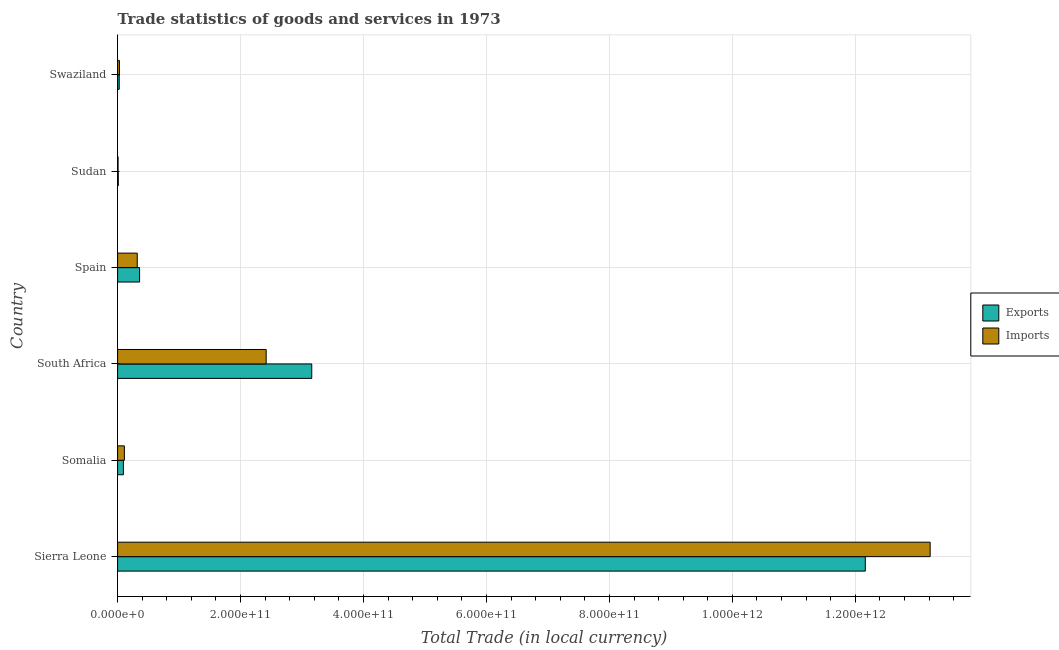How many different coloured bars are there?
Keep it short and to the point. 2. Are the number of bars per tick equal to the number of legend labels?
Offer a very short reply. Yes. How many bars are there on the 3rd tick from the bottom?
Make the answer very short. 2. What is the export of goods and services in Swaziland?
Your response must be concise. 2.62e+09. Across all countries, what is the maximum export of goods and services?
Provide a succinct answer. 1.22e+12. Across all countries, what is the minimum export of goods and services?
Give a very brief answer. 1.12e+09. In which country was the export of goods and services maximum?
Give a very brief answer. Sierra Leone. In which country was the export of goods and services minimum?
Your response must be concise. Sudan. What is the total export of goods and services in the graph?
Provide a succinct answer. 1.58e+12. What is the difference between the imports of goods and services in Somalia and that in Spain?
Provide a succinct answer. -2.10e+1. What is the difference between the imports of goods and services in Somalia and the export of goods and services in South Africa?
Provide a short and direct response. -3.05e+11. What is the average export of goods and services per country?
Provide a succinct answer. 2.63e+11. What is the difference between the imports of goods and services and export of goods and services in Sierra Leone?
Ensure brevity in your answer.  1.06e+11. In how many countries, is the imports of goods and services greater than 280000000000 LCU?
Provide a succinct answer. 1. What is the ratio of the export of goods and services in Somalia to that in Spain?
Ensure brevity in your answer.  0.26. Is the imports of goods and services in South Africa less than that in Swaziland?
Your answer should be very brief. No. Is the difference between the export of goods and services in Sierra Leone and Sudan greater than the difference between the imports of goods and services in Sierra Leone and Sudan?
Your response must be concise. No. What is the difference between the highest and the second highest imports of goods and services?
Keep it short and to the point. 1.08e+12. What is the difference between the highest and the lowest imports of goods and services?
Your answer should be very brief. 1.32e+12. In how many countries, is the export of goods and services greater than the average export of goods and services taken over all countries?
Your answer should be very brief. 2. Is the sum of the export of goods and services in Somalia and Sudan greater than the maximum imports of goods and services across all countries?
Your answer should be compact. No. What does the 2nd bar from the top in Spain represents?
Offer a very short reply. Exports. What does the 1st bar from the bottom in Spain represents?
Provide a short and direct response. Exports. How many bars are there?
Your response must be concise. 12. Are all the bars in the graph horizontal?
Offer a very short reply. Yes. How many countries are there in the graph?
Provide a succinct answer. 6. What is the difference between two consecutive major ticks on the X-axis?
Your answer should be compact. 2.00e+11. Does the graph contain grids?
Provide a short and direct response. Yes. Where does the legend appear in the graph?
Provide a short and direct response. Center right. How are the legend labels stacked?
Your answer should be compact. Vertical. What is the title of the graph?
Offer a very short reply. Trade statistics of goods and services in 1973. Does "Fraud firms" appear as one of the legend labels in the graph?
Your answer should be compact. No. What is the label or title of the X-axis?
Make the answer very short. Total Trade (in local currency). What is the label or title of the Y-axis?
Provide a short and direct response. Country. What is the Total Trade (in local currency) in Exports in Sierra Leone?
Provide a short and direct response. 1.22e+12. What is the Total Trade (in local currency) of Imports in Sierra Leone?
Provide a succinct answer. 1.32e+12. What is the Total Trade (in local currency) of Exports in Somalia?
Offer a very short reply. 9.41e+09. What is the Total Trade (in local currency) of Imports in Somalia?
Ensure brevity in your answer.  1.10e+1. What is the Total Trade (in local currency) of Exports in South Africa?
Offer a terse response. 3.16e+11. What is the Total Trade (in local currency) in Imports in South Africa?
Make the answer very short. 2.42e+11. What is the Total Trade (in local currency) of Exports in Spain?
Provide a short and direct response. 3.58e+1. What is the Total Trade (in local currency) of Imports in Spain?
Offer a terse response. 3.20e+1. What is the Total Trade (in local currency) of Exports in Sudan?
Your answer should be very brief. 1.12e+09. What is the Total Trade (in local currency) of Imports in Sudan?
Your response must be concise. 7.28e+08. What is the Total Trade (in local currency) in Exports in Swaziland?
Your answer should be very brief. 2.62e+09. What is the Total Trade (in local currency) of Imports in Swaziland?
Offer a very short reply. 2.96e+09. Across all countries, what is the maximum Total Trade (in local currency) in Exports?
Keep it short and to the point. 1.22e+12. Across all countries, what is the maximum Total Trade (in local currency) of Imports?
Offer a very short reply. 1.32e+12. Across all countries, what is the minimum Total Trade (in local currency) of Exports?
Offer a terse response. 1.12e+09. Across all countries, what is the minimum Total Trade (in local currency) of Imports?
Your answer should be compact. 7.28e+08. What is the total Total Trade (in local currency) of Exports in the graph?
Keep it short and to the point. 1.58e+12. What is the total Total Trade (in local currency) of Imports in the graph?
Keep it short and to the point. 1.61e+12. What is the difference between the Total Trade (in local currency) in Exports in Sierra Leone and that in Somalia?
Provide a short and direct response. 1.21e+12. What is the difference between the Total Trade (in local currency) in Imports in Sierra Leone and that in Somalia?
Your answer should be very brief. 1.31e+12. What is the difference between the Total Trade (in local currency) of Exports in Sierra Leone and that in South Africa?
Your response must be concise. 9.00e+11. What is the difference between the Total Trade (in local currency) in Imports in Sierra Leone and that in South Africa?
Keep it short and to the point. 1.08e+12. What is the difference between the Total Trade (in local currency) in Exports in Sierra Leone and that in Spain?
Your response must be concise. 1.18e+12. What is the difference between the Total Trade (in local currency) of Imports in Sierra Leone and that in Spain?
Make the answer very short. 1.29e+12. What is the difference between the Total Trade (in local currency) in Exports in Sierra Leone and that in Sudan?
Ensure brevity in your answer.  1.22e+12. What is the difference between the Total Trade (in local currency) in Imports in Sierra Leone and that in Sudan?
Your answer should be compact. 1.32e+12. What is the difference between the Total Trade (in local currency) of Exports in Sierra Leone and that in Swaziland?
Provide a succinct answer. 1.21e+12. What is the difference between the Total Trade (in local currency) of Imports in Sierra Leone and that in Swaziland?
Keep it short and to the point. 1.32e+12. What is the difference between the Total Trade (in local currency) of Exports in Somalia and that in South Africa?
Your answer should be very brief. -3.06e+11. What is the difference between the Total Trade (in local currency) of Imports in Somalia and that in South Africa?
Give a very brief answer. -2.31e+11. What is the difference between the Total Trade (in local currency) in Exports in Somalia and that in Spain?
Offer a terse response. -2.64e+1. What is the difference between the Total Trade (in local currency) in Imports in Somalia and that in Spain?
Your answer should be compact. -2.10e+1. What is the difference between the Total Trade (in local currency) in Exports in Somalia and that in Sudan?
Offer a very short reply. 8.29e+09. What is the difference between the Total Trade (in local currency) in Imports in Somalia and that in Sudan?
Give a very brief answer. 1.03e+1. What is the difference between the Total Trade (in local currency) of Exports in Somalia and that in Swaziland?
Give a very brief answer. 6.79e+09. What is the difference between the Total Trade (in local currency) in Imports in Somalia and that in Swaziland?
Offer a very short reply. 8.04e+09. What is the difference between the Total Trade (in local currency) of Exports in South Africa and that in Spain?
Make the answer very short. 2.80e+11. What is the difference between the Total Trade (in local currency) in Imports in South Africa and that in Spain?
Make the answer very short. 2.10e+11. What is the difference between the Total Trade (in local currency) of Exports in South Africa and that in Sudan?
Offer a terse response. 3.15e+11. What is the difference between the Total Trade (in local currency) in Imports in South Africa and that in Sudan?
Give a very brief answer. 2.41e+11. What is the difference between the Total Trade (in local currency) of Exports in South Africa and that in Swaziland?
Provide a succinct answer. 3.13e+11. What is the difference between the Total Trade (in local currency) in Imports in South Africa and that in Swaziland?
Provide a short and direct response. 2.39e+11. What is the difference between the Total Trade (in local currency) of Exports in Spain and that in Sudan?
Give a very brief answer. 3.46e+1. What is the difference between the Total Trade (in local currency) of Imports in Spain and that in Sudan?
Your answer should be compact. 3.12e+1. What is the difference between the Total Trade (in local currency) in Exports in Spain and that in Swaziland?
Offer a very short reply. 3.31e+1. What is the difference between the Total Trade (in local currency) in Imports in Spain and that in Swaziland?
Provide a short and direct response. 2.90e+1. What is the difference between the Total Trade (in local currency) in Exports in Sudan and that in Swaziland?
Your response must be concise. -1.50e+09. What is the difference between the Total Trade (in local currency) of Imports in Sudan and that in Swaziland?
Ensure brevity in your answer.  -2.23e+09. What is the difference between the Total Trade (in local currency) of Exports in Sierra Leone and the Total Trade (in local currency) of Imports in Somalia?
Offer a terse response. 1.21e+12. What is the difference between the Total Trade (in local currency) in Exports in Sierra Leone and the Total Trade (in local currency) in Imports in South Africa?
Keep it short and to the point. 9.75e+11. What is the difference between the Total Trade (in local currency) of Exports in Sierra Leone and the Total Trade (in local currency) of Imports in Spain?
Keep it short and to the point. 1.18e+12. What is the difference between the Total Trade (in local currency) of Exports in Sierra Leone and the Total Trade (in local currency) of Imports in Sudan?
Keep it short and to the point. 1.22e+12. What is the difference between the Total Trade (in local currency) in Exports in Sierra Leone and the Total Trade (in local currency) in Imports in Swaziland?
Your response must be concise. 1.21e+12. What is the difference between the Total Trade (in local currency) in Exports in Somalia and the Total Trade (in local currency) in Imports in South Africa?
Provide a succinct answer. -2.32e+11. What is the difference between the Total Trade (in local currency) in Exports in Somalia and the Total Trade (in local currency) in Imports in Spain?
Offer a very short reply. -2.26e+1. What is the difference between the Total Trade (in local currency) in Exports in Somalia and the Total Trade (in local currency) in Imports in Sudan?
Provide a short and direct response. 8.68e+09. What is the difference between the Total Trade (in local currency) in Exports in Somalia and the Total Trade (in local currency) in Imports in Swaziland?
Ensure brevity in your answer.  6.45e+09. What is the difference between the Total Trade (in local currency) in Exports in South Africa and the Total Trade (in local currency) in Imports in Spain?
Give a very brief answer. 2.84e+11. What is the difference between the Total Trade (in local currency) in Exports in South Africa and the Total Trade (in local currency) in Imports in Sudan?
Offer a very short reply. 3.15e+11. What is the difference between the Total Trade (in local currency) of Exports in South Africa and the Total Trade (in local currency) of Imports in Swaziland?
Offer a very short reply. 3.13e+11. What is the difference between the Total Trade (in local currency) of Exports in Spain and the Total Trade (in local currency) of Imports in Sudan?
Give a very brief answer. 3.50e+1. What is the difference between the Total Trade (in local currency) in Exports in Spain and the Total Trade (in local currency) in Imports in Swaziland?
Keep it short and to the point. 3.28e+1. What is the difference between the Total Trade (in local currency) of Exports in Sudan and the Total Trade (in local currency) of Imports in Swaziland?
Provide a short and direct response. -1.84e+09. What is the average Total Trade (in local currency) of Exports per country?
Your response must be concise. 2.63e+11. What is the average Total Trade (in local currency) in Imports per country?
Offer a terse response. 2.68e+11. What is the difference between the Total Trade (in local currency) of Exports and Total Trade (in local currency) of Imports in Sierra Leone?
Your response must be concise. -1.06e+11. What is the difference between the Total Trade (in local currency) of Exports and Total Trade (in local currency) of Imports in Somalia?
Your answer should be very brief. -1.59e+09. What is the difference between the Total Trade (in local currency) in Exports and Total Trade (in local currency) in Imports in South Africa?
Offer a terse response. 7.41e+1. What is the difference between the Total Trade (in local currency) of Exports and Total Trade (in local currency) of Imports in Spain?
Ensure brevity in your answer.  3.80e+09. What is the difference between the Total Trade (in local currency) of Exports and Total Trade (in local currency) of Imports in Sudan?
Ensure brevity in your answer.  3.88e+08. What is the difference between the Total Trade (in local currency) of Exports and Total Trade (in local currency) of Imports in Swaziland?
Make the answer very short. -3.40e+08. What is the ratio of the Total Trade (in local currency) in Exports in Sierra Leone to that in Somalia?
Your response must be concise. 129.29. What is the ratio of the Total Trade (in local currency) of Imports in Sierra Leone to that in Somalia?
Provide a succinct answer. 120.18. What is the ratio of the Total Trade (in local currency) in Exports in Sierra Leone to that in South Africa?
Offer a very short reply. 3.85. What is the ratio of the Total Trade (in local currency) of Imports in Sierra Leone to that in South Africa?
Provide a succinct answer. 5.47. What is the ratio of the Total Trade (in local currency) in Exports in Sierra Leone to that in Spain?
Make the answer very short. 34.01. What is the ratio of the Total Trade (in local currency) of Imports in Sierra Leone to that in Spain?
Your response must be concise. 41.36. What is the ratio of the Total Trade (in local currency) in Exports in Sierra Leone to that in Sudan?
Offer a very short reply. 1089.86. What is the ratio of the Total Trade (in local currency) in Imports in Sierra Leone to that in Sudan?
Your response must be concise. 1814.78. What is the ratio of the Total Trade (in local currency) of Exports in Sierra Leone to that in Swaziland?
Ensure brevity in your answer.  464.09. What is the ratio of the Total Trade (in local currency) in Imports in Sierra Leone to that in Swaziland?
Your answer should be compact. 446.43. What is the ratio of the Total Trade (in local currency) in Exports in Somalia to that in South Africa?
Offer a very short reply. 0.03. What is the ratio of the Total Trade (in local currency) in Imports in Somalia to that in South Africa?
Provide a short and direct response. 0.05. What is the ratio of the Total Trade (in local currency) in Exports in Somalia to that in Spain?
Your response must be concise. 0.26. What is the ratio of the Total Trade (in local currency) in Imports in Somalia to that in Spain?
Provide a short and direct response. 0.34. What is the ratio of the Total Trade (in local currency) in Exports in Somalia to that in Sudan?
Your answer should be very brief. 8.43. What is the ratio of the Total Trade (in local currency) in Imports in Somalia to that in Sudan?
Offer a terse response. 15.1. What is the ratio of the Total Trade (in local currency) in Exports in Somalia to that in Swaziland?
Give a very brief answer. 3.59. What is the ratio of the Total Trade (in local currency) of Imports in Somalia to that in Swaziland?
Provide a short and direct response. 3.71. What is the ratio of the Total Trade (in local currency) in Exports in South Africa to that in Spain?
Offer a very short reply. 8.83. What is the ratio of the Total Trade (in local currency) of Imports in South Africa to that in Spain?
Your answer should be compact. 7.56. What is the ratio of the Total Trade (in local currency) in Exports in South Africa to that in Sudan?
Offer a terse response. 282.99. What is the ratio of the Total Trade (in local currency) in Imports in South Africa to that in Sudan?
Keep it short and to the point. 331.8. What is the ratio of the Total Trade (in local currency) of Exports in South Africa to that in Swaziland?
Make the answer very short. 120.5. What is the ratio of the Total Trade (in local currency) of Imports in South Africa to that in Swaziland?
Offer a very short reply. 81.62. What is the ratio of the Total Trade (in local currency) of Exports in Spain to that in Sudan?
Offer a terse response. 32.04. What is the ratio of the Total Trade (in local currency) of Imports in Spain to that in Sudan?
Your answer should be compact. 43.88. What is the ratio of the Total Trade (in local currency) of Exports in Spain to that in Swaziland?
Your response must be concise. 13.65. What is the ratio of the Total Trade (in local currency) of Imports in Spain to that in Swaziland?
Your answer should be very brief. 10.79. What is the ratio of the Total Trade (in local currency) in Exports in Sudan to that in Swaziland?
Your answer should be very brief. 0.43. What is the ratio of the Total Trade (in local currency) in Imports in Sudan to that in Swaziland?
Ensure brevity in your answer.  0.25. What is the difference between the highest and the second highest Total Trade (in local currency) of Exports?
Provide a succinct answer. 9.00e+11. What is the difference between the highest and the second highest Total Trade (in local currency) of Imports?
Ensure brevity in your answer.  1.08e+12. What is the difference between the highest and the lowest Total Trade (in local currency) in Exports?
Keep it short and to the point. 1.22e+12. What is the difference between the highest and the lowest Total Trade (in local currency) of Imports?
Make the answer very short. 1.32e+12. 